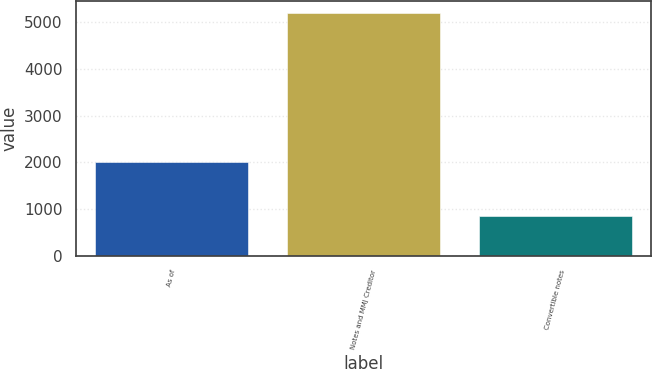<chart> <loc_0><loc_0><loc_500><loc_500><bar_chart><fcel>As of<fcel>Notes and MMJ Creditor<fcel>Convertible notes<nl><fcel>2019<fcel>5194<fcel>852<nl></chart> 